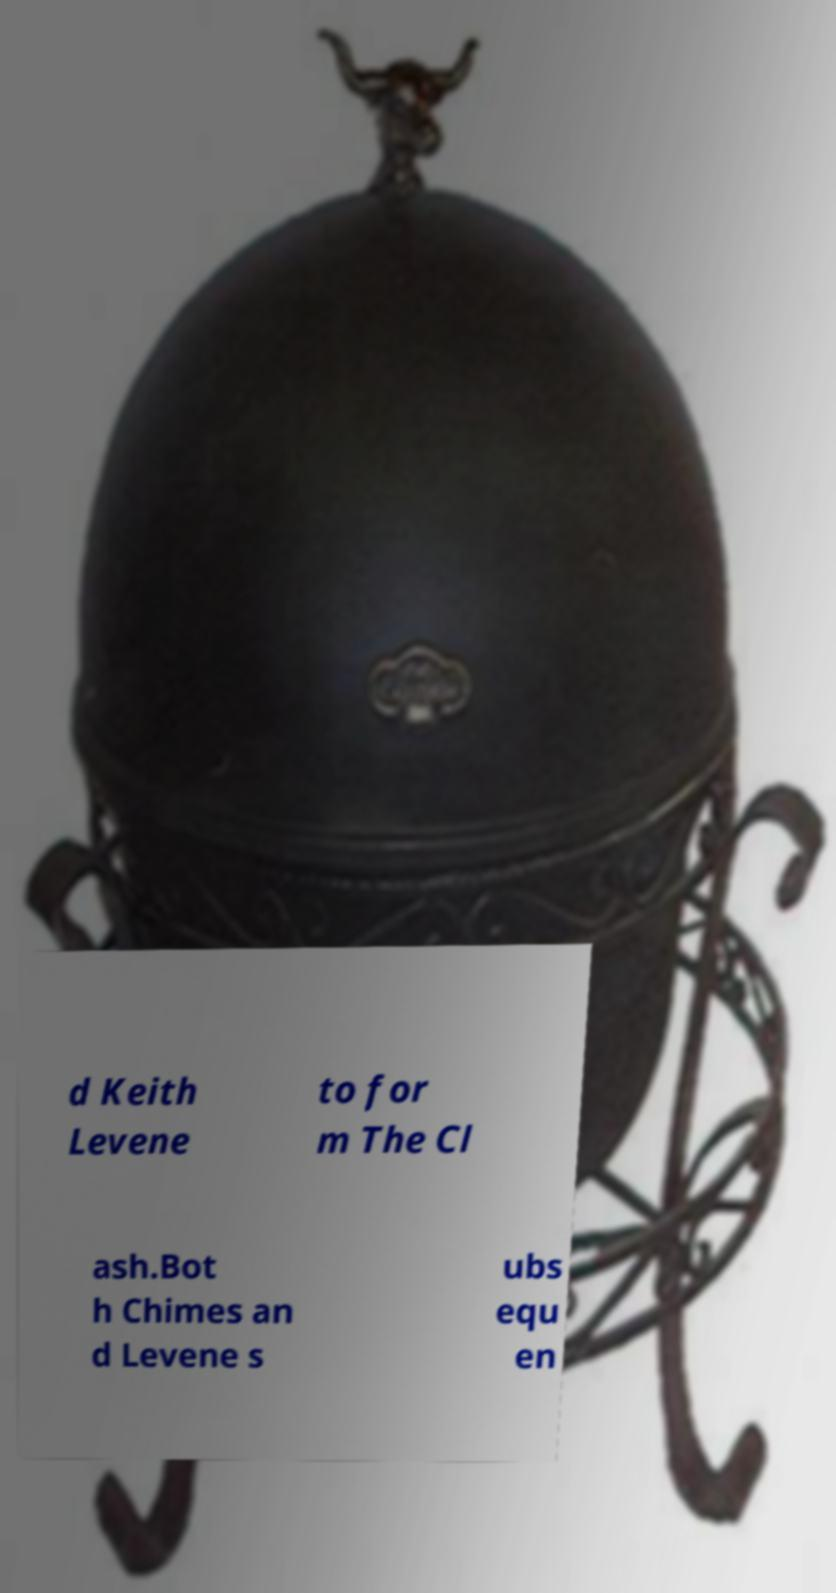Can you accurately transcribe the text from the provided image for me? d Keith Levene to for m The Cl ash.Bot h Chimes an d Levene s ubs equ en 